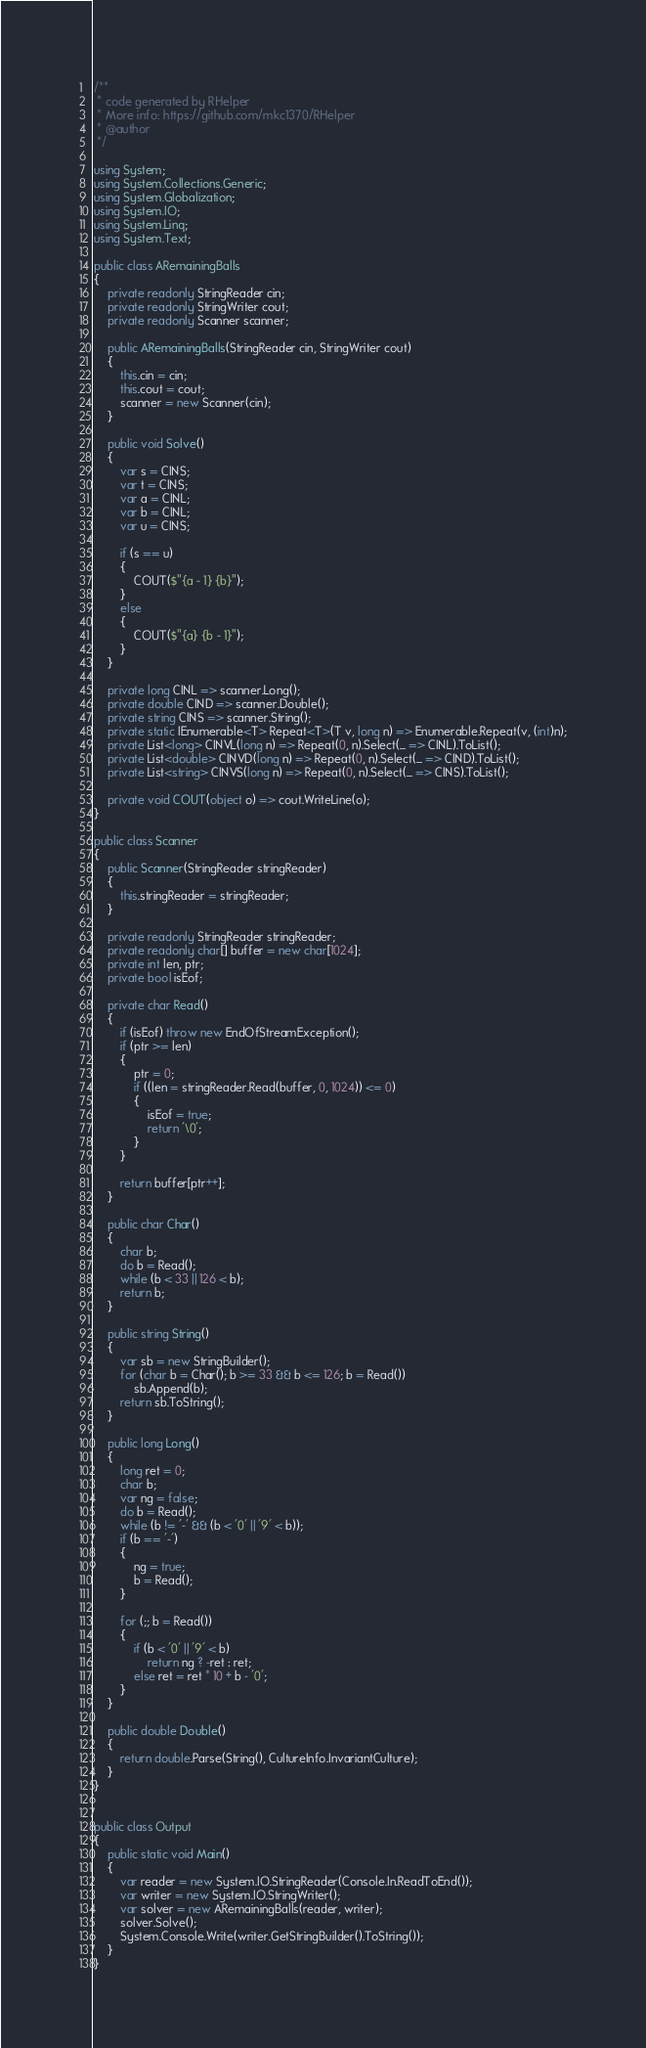Convert code to text. <code><loc_0><loc_0><loc_500><loc_500><_C#_>/**
 * code generated by RHelper
 * More info: https://github.com/mkc1370/RHelper
 * @author 
 */

using System;
using System.Collections.Generic;
using System.Globalization;
using System.IO;
using System.Linq;
using System.Text;

public class ARemainingBalls
{
    private readonly StringReader cin;
    private readonly StringWriter cout;
    private readonly Scanner scanner;

    public ARemainingBalls(StringReader cin, StringWriter cout)
    {
        this.cin = cin;
        this.cout = cout;
        scanner = new Scanner(cin);
    }

    public void Solve()
    {
        var s = CINS;
        var t = CINS;
        var a = CINL;
        var b = CINL;
        var u = CINS;

        if (s == u)
        {
            COUT($"{a - 1} {b}");
        }
        else
        {
            COUT($"{a} {b - 1}");
        }
    }

    private long CINL => scanner.Long();
    private double CIND => scanner.Double();
    private string CINS => scanner.String();
    private static IEnumerable<T> Repeat<T>(T v, long n) => Enumerable.Repeat(v, (int)n);
    private List<long> CINVL(long n) => Repeat(0, n).Select(_ => CINL).ToList();
    private List<double> CINVD(long n) => Repeat(0, n).Select(_ => CIND).ToList();
    private List<string> CINVS(long n) => Repeat(0, n).Select(_ => CINS).ToList();

    private void COUT(object o) => cout.WriteLine(o);
}

public class Scanner
{
    public Scanner(StringReader stringReader)
    {
        this.stringReader = stringReader;
    }

    private readonly StringReader stringReader;
    private readonly char[] buffer = new char[1024];
    private int len, ptr;
    private bool isEof;

    private char Read()
    {
        if (isEof) throw new EndOfStreamException();
        if (ptr >= len)
        {
            ptr = 0;
            if ((len = stringReader.Read(buffer, 0, 1024)) <= 0)
            {
                isEof = true;
                return '\0';
            }
        }

        return buffer[ptr++];
    }

    public char Char()
    {
        char b;
        do b = Read();
        while (b < 33 || 126 < b);
        return b;
    }

    public string String()
    {
        var sb = new StringBuilder();
        for (char b = Char(); b >= 33 && b <= 126; b = Read())
            sb.Append(b);
        return sb.ToString();
    }

    public long Long()
    {
        long ret = 0;
        char b;
        var ng = false;
        do b = Read();
        while (b != '-' && (b < '0' || '9' < b));
        if (b == '-')
        {
            ng = true;
            b = Read();
        }

        for (;; b = Read())
        {
            if (b < '0' || '9' < b)
                return ng ? -ret : ret;
            else ret = ret * 10 + b - '0';
        }
    }

    public double Double()
    {
        return double.Parse(String(), CultureInfo.InvariantCulture);
    }
}


public class Output
{
	public static void Main()
	{
		var reader = new System.IO.StringReader(Console.In.ReadToEnd());
		var writer = new System.IO.StringWriter();
		var solver = new ARemainingBalls(reader, writer);
		solver.Solve();
		System.Console.Write(writer.GetStringBuilder().ToString());
	}
}
</code> 